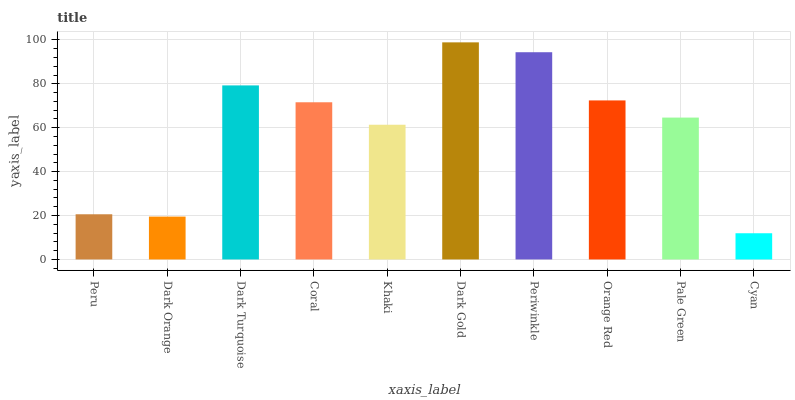Is Cyan the minimum?
Answer yes or no. Yes. Is Dark Gold the maximum?
Answer yes or no. Yes. Is Dark Orange the minimum?
Answer yes or no. No. Is Dark Orange the maximum?
Answer yes or no. No. Is Peru greater than Dark Orange?
Answer yes or no. Yes. Is Dark Orange less than Peru?
Answer yes or no. Yes. Is Dark Orange greater than Peru?
Answer yes or no. No. Is Peru less than Dark Orange?
Answer yes or no. No. Is Coral the high median?
Answer yes or no. Yes. Is Pale Green the low median?
Answer yes or no. Yes. Is Orange Red the high median?
Answer yes or no. No. Is Dark Turquoise the low median?
Answer yes or no. No. 